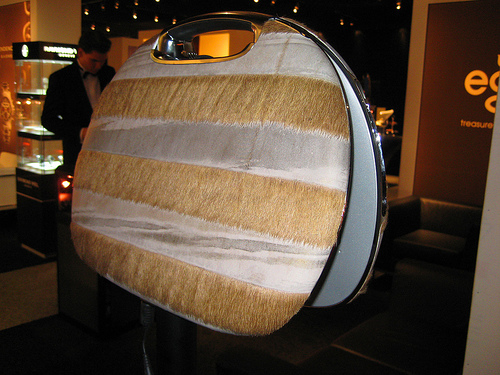<image>
Can you confirm if the bag is on the man? No. The bag is not positioned on the man. They may be near each other, but the bag is not supported by or resting on top of the man. 